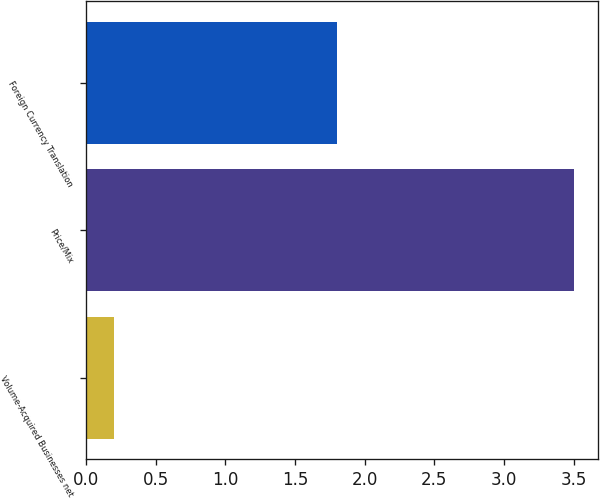Convert chart to OTSL. <chart><loc_0><loc_0><loc_500><loc_500><bar_chart><fcel>Volume-Acquired Businesses net<fcel>Price/Mix<fcel>Foreign Currency Translation<nl><fcel>0.2<fcel>3.5<fcel>1.8<nl></chart> 